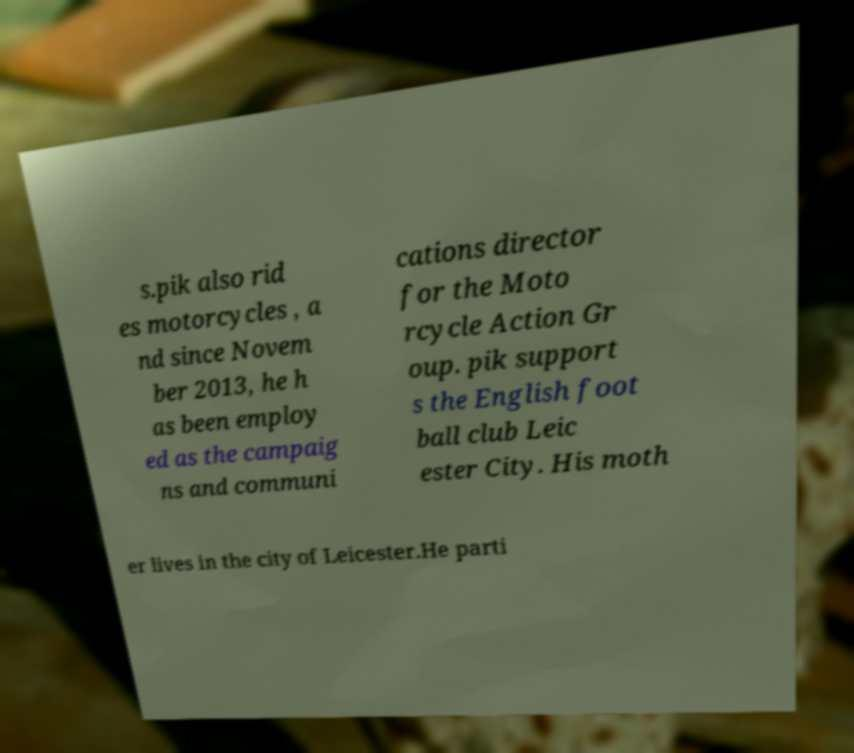Could you assist in decoding the text presented in this image and type it out clearly? s.pik also rid es motorcycles , a nd since Novem ber 2013, he h as been employ ed as the campaig ns and communi cations director for the Moto rcycle Action Gr oup. pik support s the English foot ball club Leic ester City. His moth er lives in the city of Leicester.He parti 